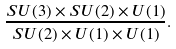Convert formula to latex. <formula><loc_0><loc_0><loc_500><loc_500>\frac { S U ( 3 ) \times S U ( 2 ) \times U ( 1 ) } { S U ( 2 ) \times U ( 1 ) \times U ( 1 ) } .</formula> 